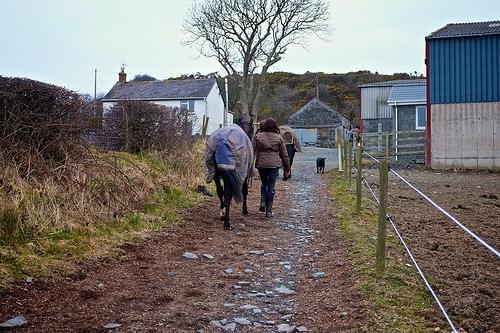How many horses are in the picture?
Give a very brief answer. 2. How many buildings do you see?
Give a very brief answer. 5. 